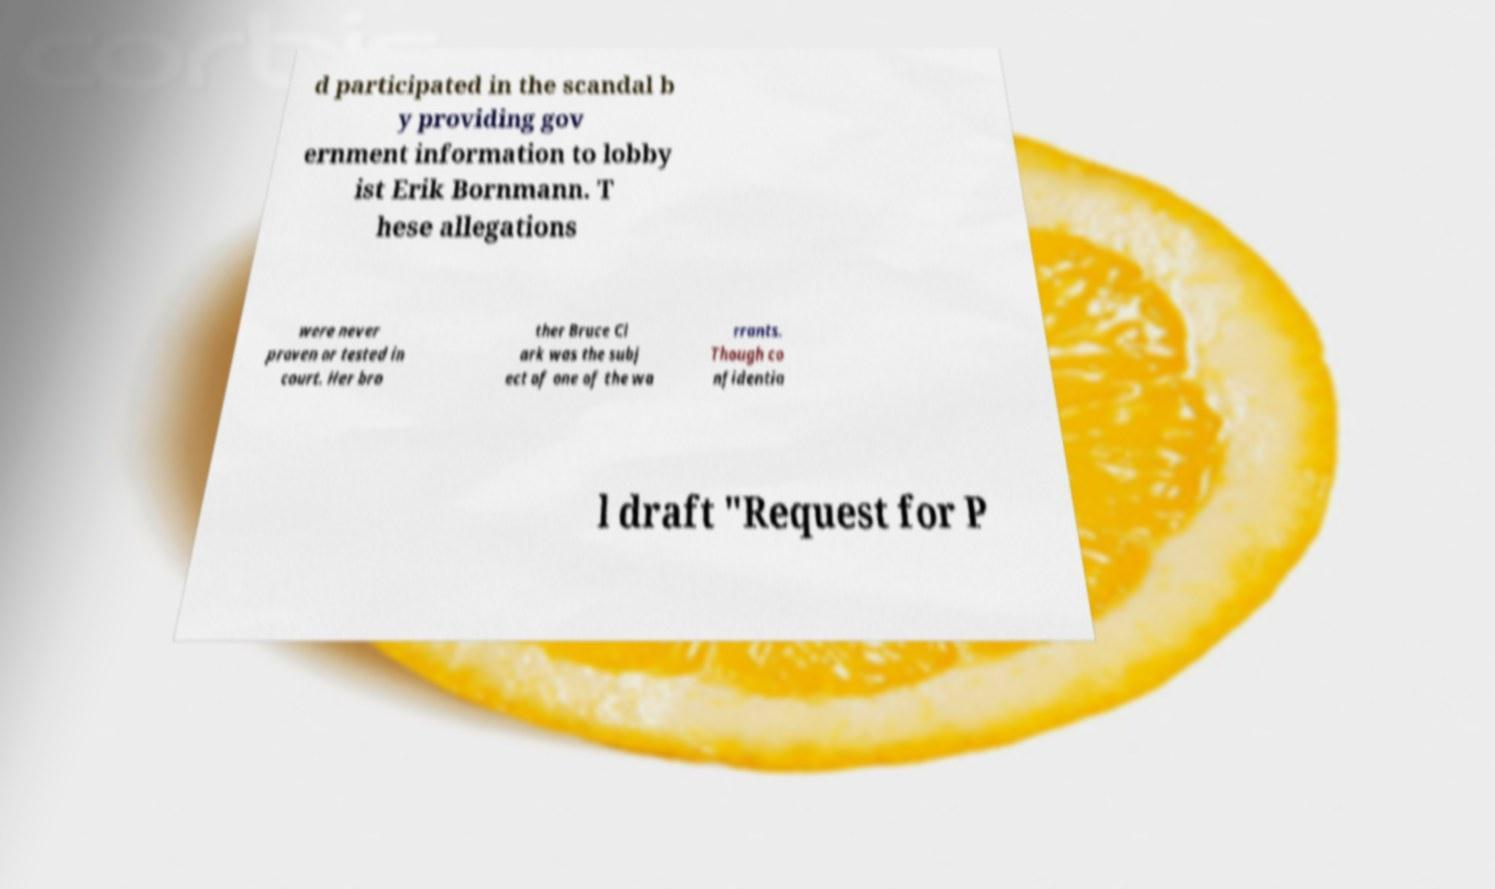There's text embedded in this image that I need extracted. Can you transcribe it verbatim? d participated in the scandal b y providing gov ernment information to lobby ist Erik Bornmann. T hese allegations were never proven or tested in court. Her bro ther Bruce Cl ark was the subj ect of one of the wa rrants. Though co nfidentia l draft "Request for P 